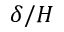<formula> <loc_0><loc_0><loc_500><loc_500>\delta / H</formula> 